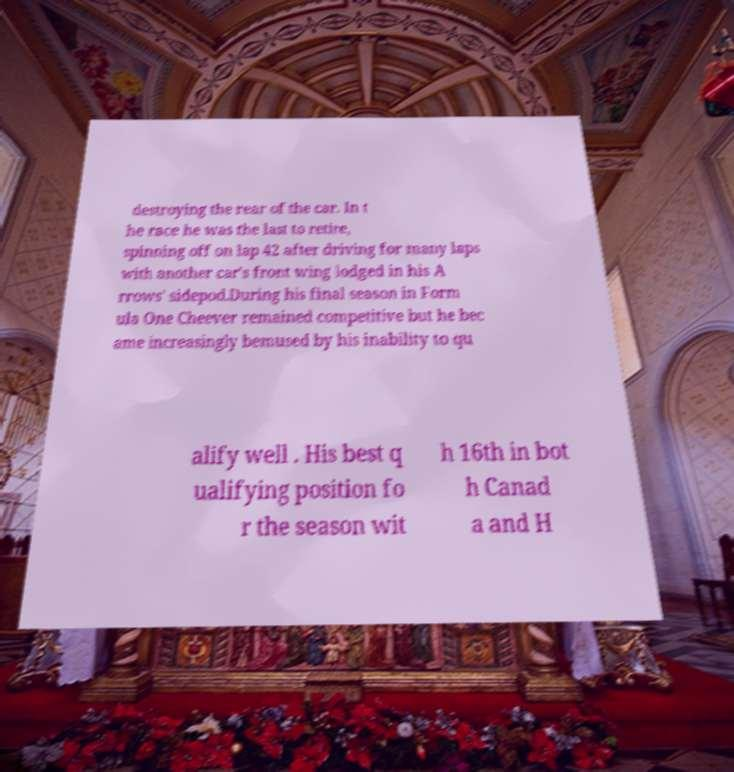I need the written content from this picture converted into text. Can you do that? destroying the rear of the car. In t he race he was the last to retire, spinning off on lap 42 after driving for many laps with another car's front wing lodged in his A rrows' sidepod.During his final season in Form ula One Cheever remained competitive but he bec ame increasingly bemused by his inability to qu alify well . His best q ualifying position fo r the season wit h 16th in bot h Canad a and H 